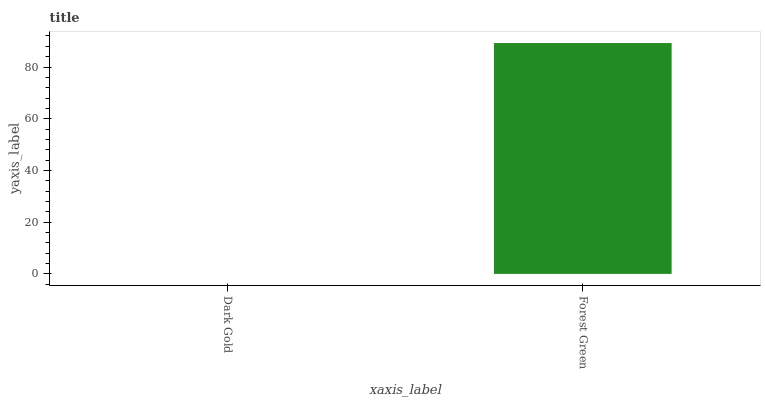Is Dark Gold the minimum?
Answer yes or no. Yes. Is Forest Green the maximum?
Answer yes or no. Yes. Is Forest Green the minimum?
Answer yes or no. No. Is Forest Green greater than Dark Gold?
Answer yes or no. Yes. Is Dark Gold less than Forest Green?
Answer yes or no. Yes. Is Dark Gold greater than Forest Green?
Answer yes or no. No. Is Forest Green less than Dark Gold?
Answer yes or no. No. Is Forest Green the high median?
Answer yes or no. Yes. Is Dark Gold the low median?
Answer yes or no. Yes. Is Dark Gold the high median?
Answer yes or no. No. Is Forest Green the low median?
Answer yes or no. No. 